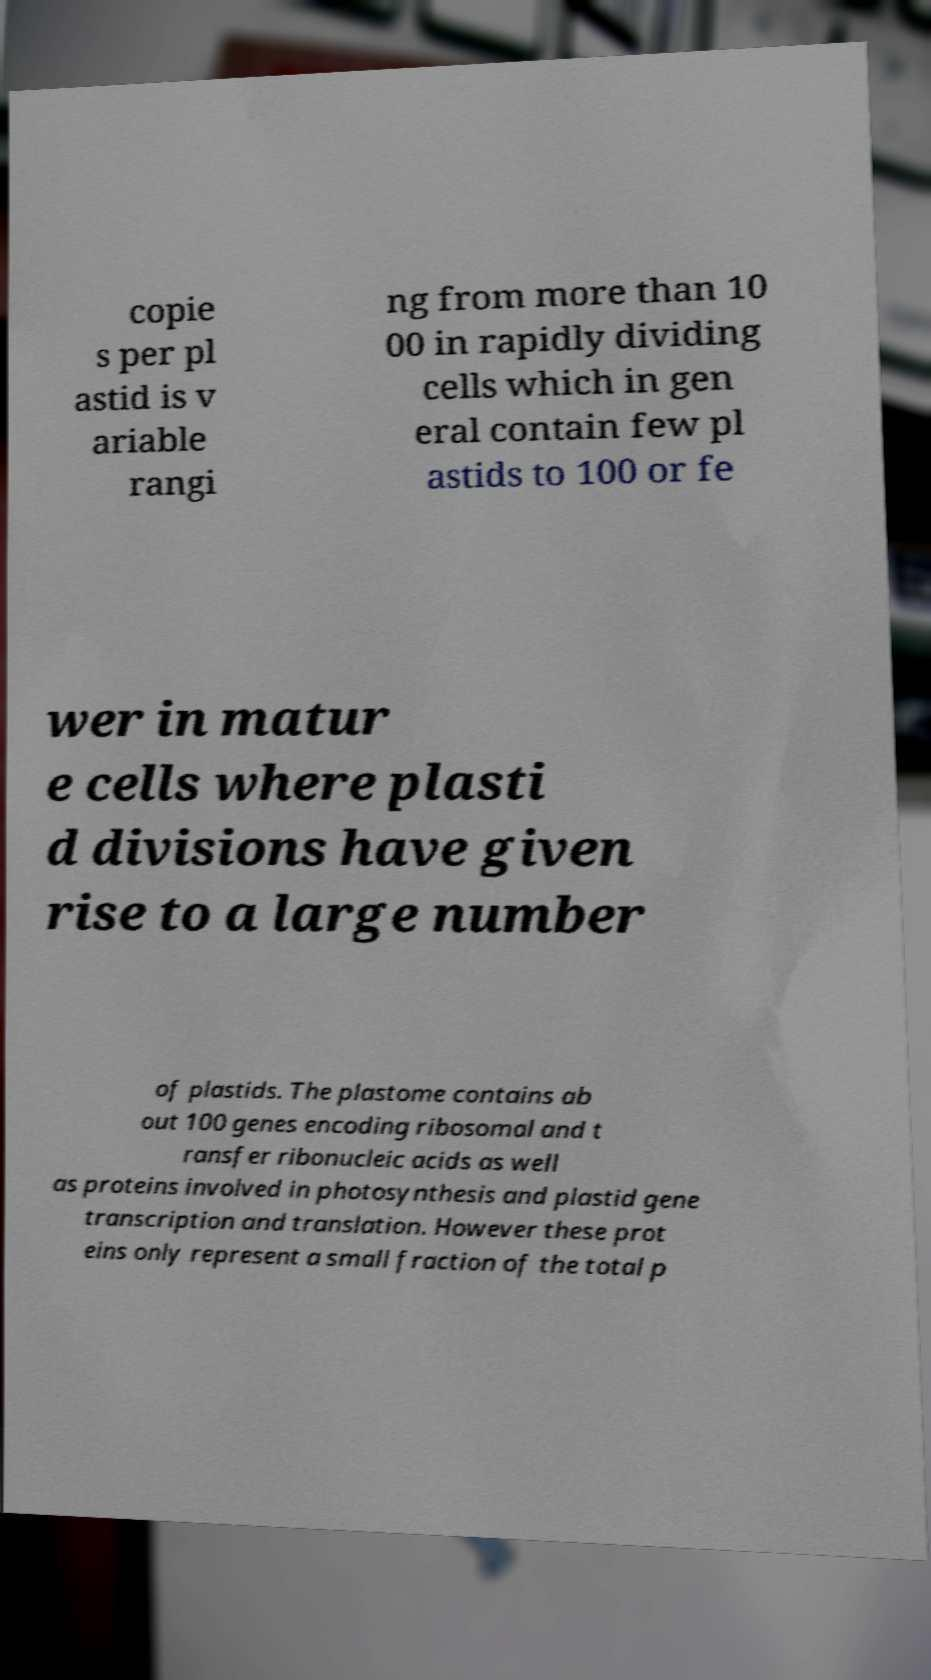Can you accurately transcribe the text from the provided image for me? copie s per pl astid is v ariable rangi ng from more than 10 00 in rapidly dividing cells which in gen eral contain few pl astids to 100 or fe wer in matur e cells where plasti d divisions have given rise to a large number of plastids. The plastome contains ab out 100 genes encoding ribosomal and t ransfer ribonucleic acids as well as proteins involved in photosynthesis and plastid gene transcription and translation. However these prot eins only represent a small fraction of the total p 